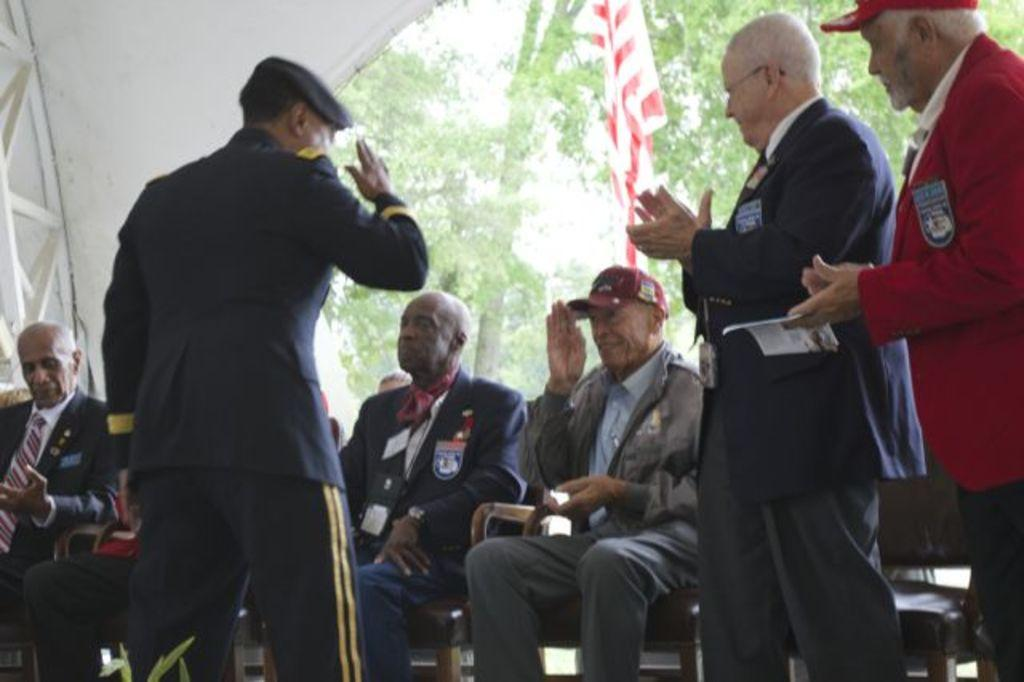How many people are in the image? There are people in the image, but the exact number is not specified. What are some of the people doing in the image? Some people are sitting, and some people are standing. What can be seen flying in the image? There is a flag visible in the image. What type of natural scenery is visible in the background of the image? There are trees in the background of the image. What type of jelly is being used to hold the flag in the image? There is no jelly present in the image, and the flag is not being held by any jelly. How does the coastline look in the image? There is no mention of a coastline in the image, so it cannot be described. 